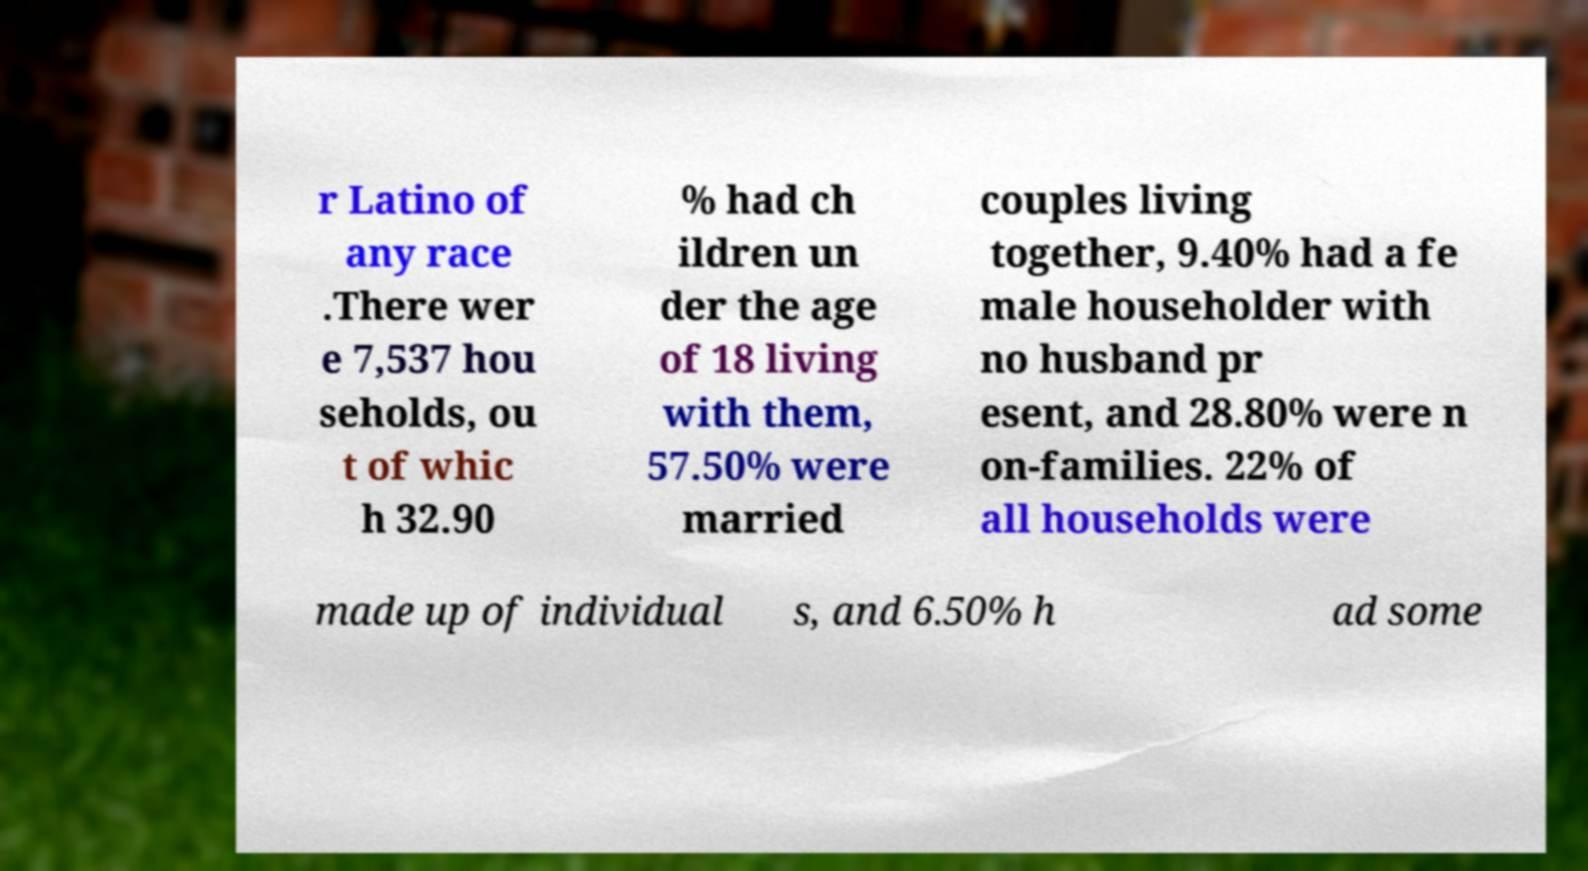For documentation purposes, I need the text within this image transcribed. Could you provide that? r Latino of any race .There wer e 7,537 hou seholds, ou t of whic h 32.90 % had ch ildren un der the age of 18 living with them, 57.50% were married couples living together, 9.40% had a fe male householder with no husband pr esent, and 28.80% were n on-families. 22% of all households were made up of individual s, and 6.50% h ad some 